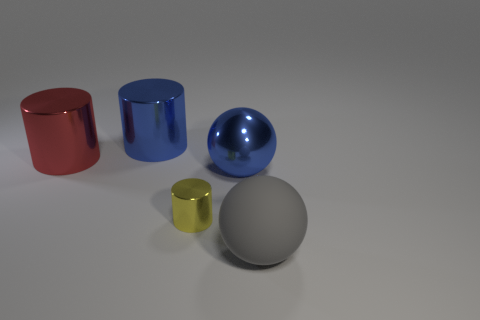Subtract all big shiny cylinders. How many cylinders are left? 1 Add 2 gray metal spheres. How many objects exist? 7 Subtract all blue balls. How many balls are left? 1 Subtract 1 cylinders. How many cylinders are left? 2 Subtract all red blocks. How many purple balls are left? 0 Subtract all big gray matte balls. Subtract all big gray things. How many objects are left? 3 Add 3 red shiny cylinders. How many red shiny cylinders are left? 4 Add 4 red metal objects. How many red metal objects exist? 5 Subtract 1 blue cylinders. How many objects are left? 4 Subtract all cylinders. How many objects are left? 2 